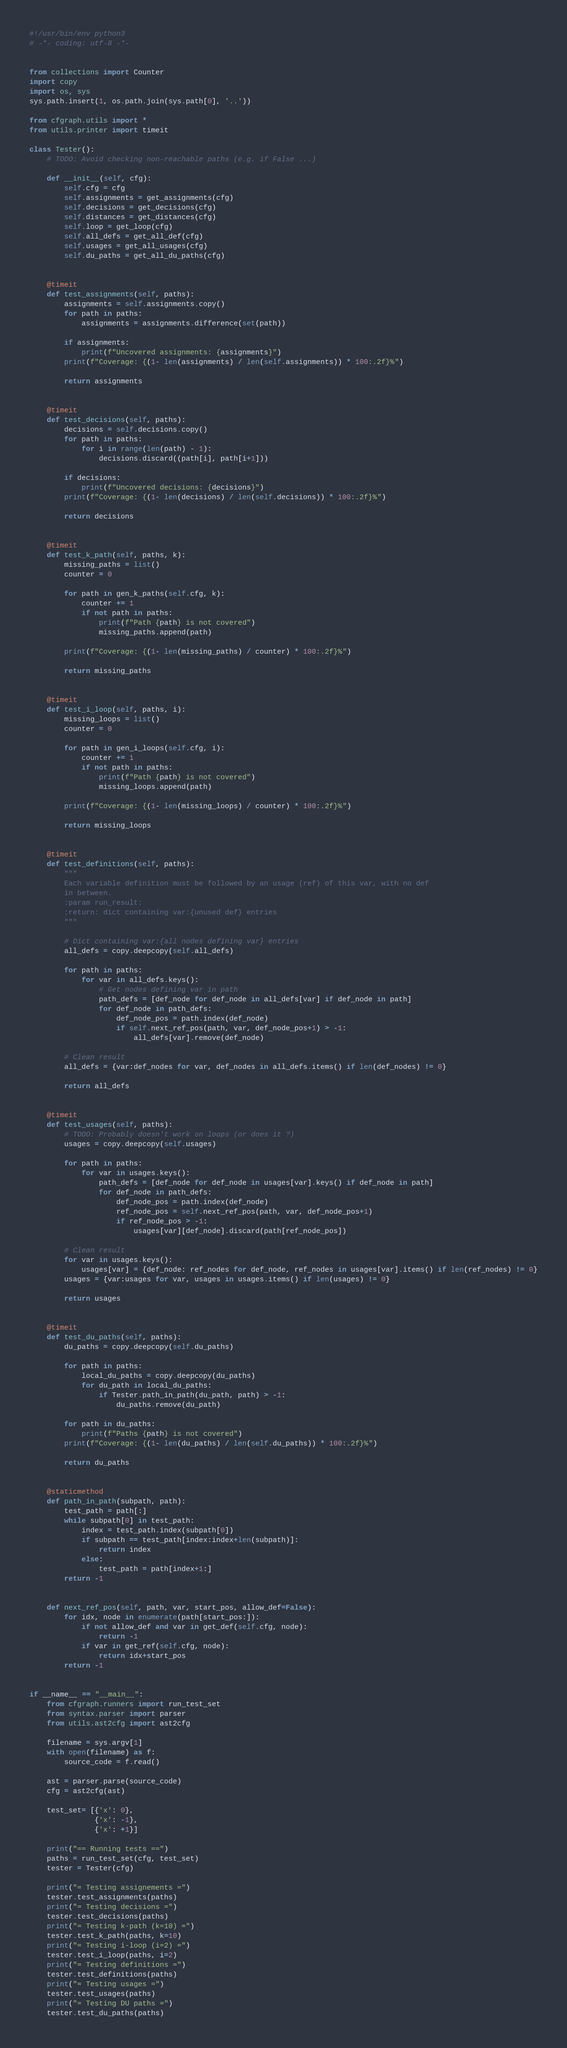<code> <loc_0><loc_0><loc_500><loc_500><_Python_>#!/usr/bin/env python3
# -*- coding: utf-8 -*-


from collections import Counter
import copy
import os, sys
sys.path.insert(1, os.path.join(sys.path[0], '..'))

from cfgraph.utils import *
from utils.printer import timeit

class Tester():
    # TODO: Avoid checking non-reachable paths (e.g. if False ...)

    def __init__(self, cfg):
        self.cfg = cfg
        self.assignments = get_assignments(cfg)
        self.decisions = get_decisions(cfg)
        self.distances = get_distances(cfg)
        self.loop = get_loop(cfg)
        self.all_defs = get_all_def(cfg)
        self.usages = get_all_usages(cfg)
        self.du_paths = get_all_du_paths(cfg)


    @timeit
    def test_assignments(self, paths):
        assignments = self.assignments.copy()
        for path in paths:
            assignments = assignments.difference(set(path))

        if assignments:
            print(f"Uncovered assignments: {assignments}")
        print(f"Coverage: {(1- len(assignments) / len(self.assignments)) * 100:.2f}%")

        return assignments


    @timeit
    def test_decisions(self, paths):
        decisions = self.decisions.copy()
        for path in paths:
            for i in range(len(path) - 1):
                decisions.discard((path[i], path[i+1]))

        if decisions:
            print(f"Uncovered decisions: {decisions}")
        print(f"Coverage: {(1- len(decisions) / len(self.decisions)) * 100:.2f}%")

        return decisions


    @timeit
    def test_k_path(self, paths, k):
        missing_paths = list()
        counter = 0

        for path in gen_k_paths(self.cfg, k):
            counter += 1
            if not path in paths:
                print(f"Path {path} is not covered")
                missing_paths.append(path)

        print(f"Coverage: {(1- len(missing_paths) / counter) * 100:.2f}%")

        return missing_paths


    @timeit
    def test_i_loop(self, paths, i):
        missing_loops = list()
        counter = 0

        for path in gen_i_loops(self.cfg, i):
            counter += 1
            if not path in paths:
                print(f"Path {path} is not covered")
                missing_loops.append(path)

        print(f"Coverage: {(1- len(missing_loops) / counter) * 100:.2f}%")

        return missing_loops


    @timeit
    def test_definitions(self, paths):
        """
        Each variable definition must be followed by an usage (ref) of this var, with no def
        in between.
        :param run_result:
        :return: dict containing var:{unused def} entries
        """

        # Dict containing var:{all nodes defining var} entries
        all_defs = copy.deepcopy(self.all_defs)

        for path in paths:
            for var in all_defs.keys():
                # Get nodes defining var in path
                path_defs = [def_node for def_node in all_defs[var] if def_node in path]
                for def_node in path_defs:
                    def_node_pos = path.index(def_node)
                    if self.next_ref_pos(path, var, def_node_pos+1) > -1:
                        all_defs[var].remove(def_node)

        # Clean result
        all_defs = {var:def_nodes for var, def_nodes in all_defs.items() if len(def_nodes) != 0}

        return all_defs


    @timeit
    def test_usages(self, paths):
        # TODO: Probably doesn't work on loops (or does it ?)
        usages = copy.deepcopy(self.usages)

        for path in paths:
            for var in usages.keys():
                path_defs = [def_node for def_node in usages[var].keys() if def_node in path]
                for def_node in path_defs:
                    def_node_pos = path.index(def_node)
                    ref_node_pos = self.next_ref_pos(path, var, def_node_pos+1)
                    if ref_node_pos > -1:
                        usages[var][def_node].discard(path[ref_node_pos])

        # Clean result
        for var in usages.keys():
            usages[var] = {def_node: ref_nodes for def_node, ref_nodes in usages[var].items() if len(ref_nodes) != 0}
        usages = {var:usages for var, usages in usages.items() if len(usages) != 0}

        return usages


    @timeit
    def test_du_paths(self, paths):
        du_paths = copy.deepcopy(self.du_paths)

        for path in paths:
            local_du_paths = copy.deepcopy(du_paths)
            for du_path in local_du_paths:
                if Tester.path_in_path(du_path, path) > -1:
                    du_paths.remove(du_path)

        for path in du_paths:
            print(f"Paths {path} is not covered")
        print(f"Coverage: {(1- len(du_paths) / len(self.du_paths)) * 100:.2f}%")

        return du_paths


    @staticmethod
    def path_in_path(subpath, path):
        test_path = path[:]
        while subpath[0] in test_path:
            index = test_path.index(subpath[0])
            if subpath == test_path[index:index+len(subpath)]:
                return index
            else:
                test_path = path[index+1:]
        return -1


    def next_ref_pos(self, path, var, start_pos, allow_def=False):
        for idx, node in enumerate(path[start_pos:]):
            if not allow_def and var in get_def(self.cfg, node):
                return -1
            if var in get_ref(self.cfg, node):
                return idx+start_pos
        return -1


if __name__ == "__main__":
    from cfgraph.runners import run_test_set
    from syntax.parser import parser
    from utils.ast2cfg import ast2cfg

    filename = sys.argv[1]
    with open(filename) as f:
        source_code = f.read()

    ast = parser.parse(source_code)
    cfg = ast2cfg(ast)

    test_set= [{'x': 0},
               {'x': -1},
               {'x': +1}]

    print("== Running tests ==")
    paths = run_test_set(cfg, test_set)
    tester = Tester(cfg)

    print("= Testing assignements =")
    tester.test_assignments(paths)
    print("= Testing decisions =")
    tester.test_decisions(paths)
    print("= Testing k-path (k=10) =")
    tester.test_k_path(paths, k=10)
    print("= Testing i-loop (i=2) =")
    tester.test_i_loop(paths, i=2)
    print("= Testing definitions =")
    tester.test_definitions(paths)
    print("= Testing usages =")
    tester.test_usages(paths)
    print("= Testing DU paths =")
    tester.test_du_paths(paths)
</code> 